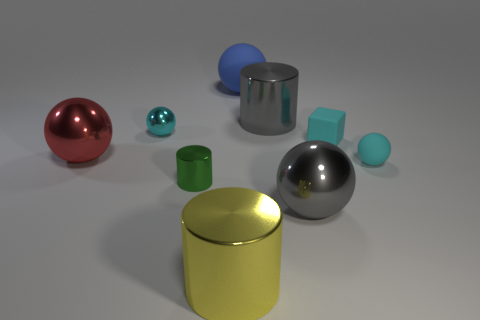What is the shape of the green thing that is the same size as the cyan rubber block?
Make the answer very short. Cylinder. How many other things are there of the same color as the small metal cylinder?
Keep it short and to the point. 0. How many other things are made of the same material as the big red sphere?
Offer a terse response. 5. Is the size of the green metal cylinder the same as the cyan sphere right of the green shiny cylinder?
Your answer should be very brief. Yes. What color is the small cylinder?
Your answer should be compact. Green. There is a big gray shiny object that is behind the cyan object that is in front of the large red sphere that is on the left side of the big gray ball; what shape is it?
Your response must be concise. Cylinder. The tiny cyan thing that is on the left side of the blue ball behind the rubber cube is made of what material?
Provide a short and direct response. Metal. There is a green thing that is made of the same material as the yellow cylinder; what shape is it?
Your answer should be very brief. Cylinder. Are there any other things that are the same shape as the green metallic thing?
Keep it short and to the point. Yes. There is a tiny cyan matte block; what number of cyan shiny balls are on the right side of it?
Ensure brevity in your answer.  0. 